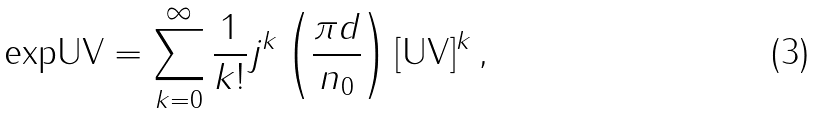Convert formula to latex. <formula><loc_0><loc_0><loc_500><loc_500>\text {expUV} = \sum _ { k = 0 } ^ { \infty } \frac { 1 } { k ! } j ^ { k } \left ( \frac { \pi d } { n _ { 0 } } \right ) [ \text {UV} ] ^ { k } \, ,</formula> 